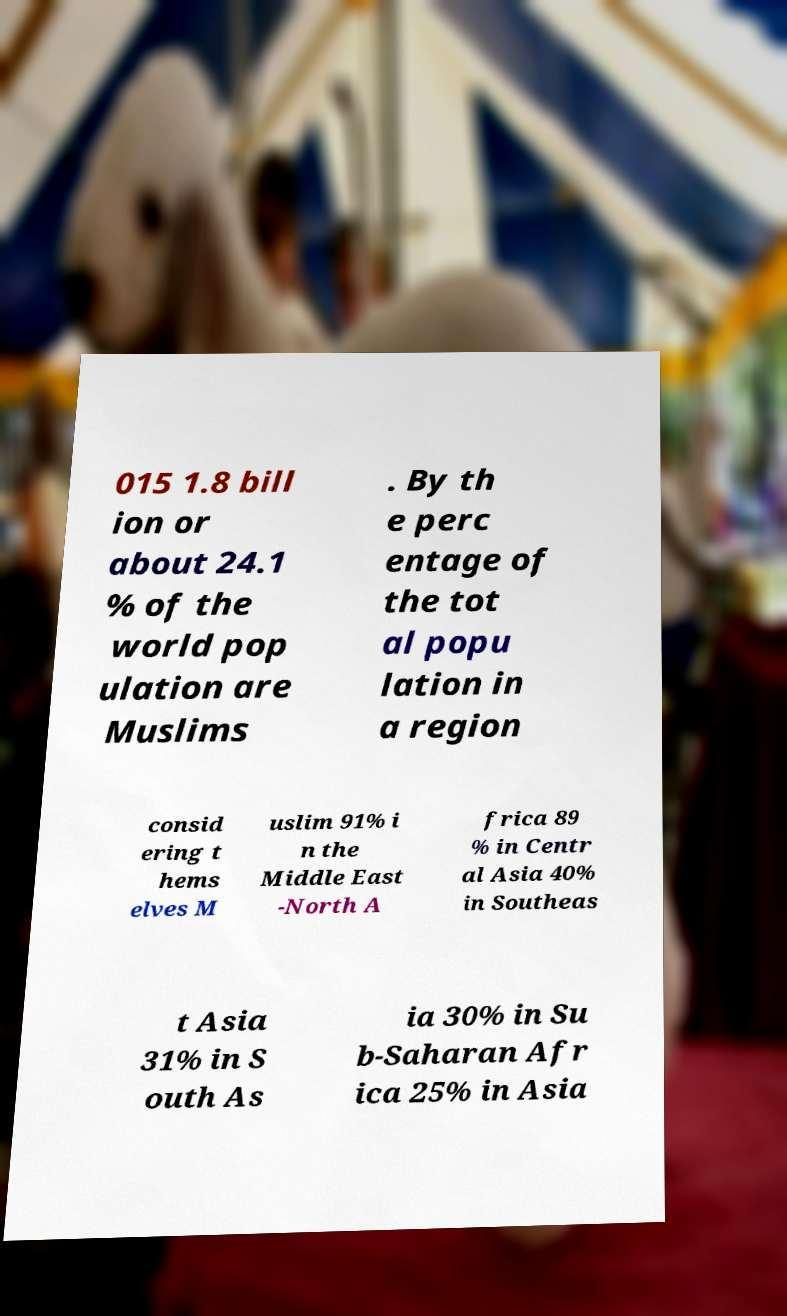Can you read and provide the text displayed in the image?This photo seems to have some interesting text. Can you extract and type it out for me? 015 1.8 bill ion or about 24.1 % of the world pop ulation are Muslims . By th e perc entage of the tot al popu lation in a region consid ering t hems elves M uslim 91% i n the Middle East -North A frica 89 % in Centr al Asia 40% in Southeas t Asia 31% in S outh As ia 30% in Su b-Saharan Afr ica 25% in Asia 